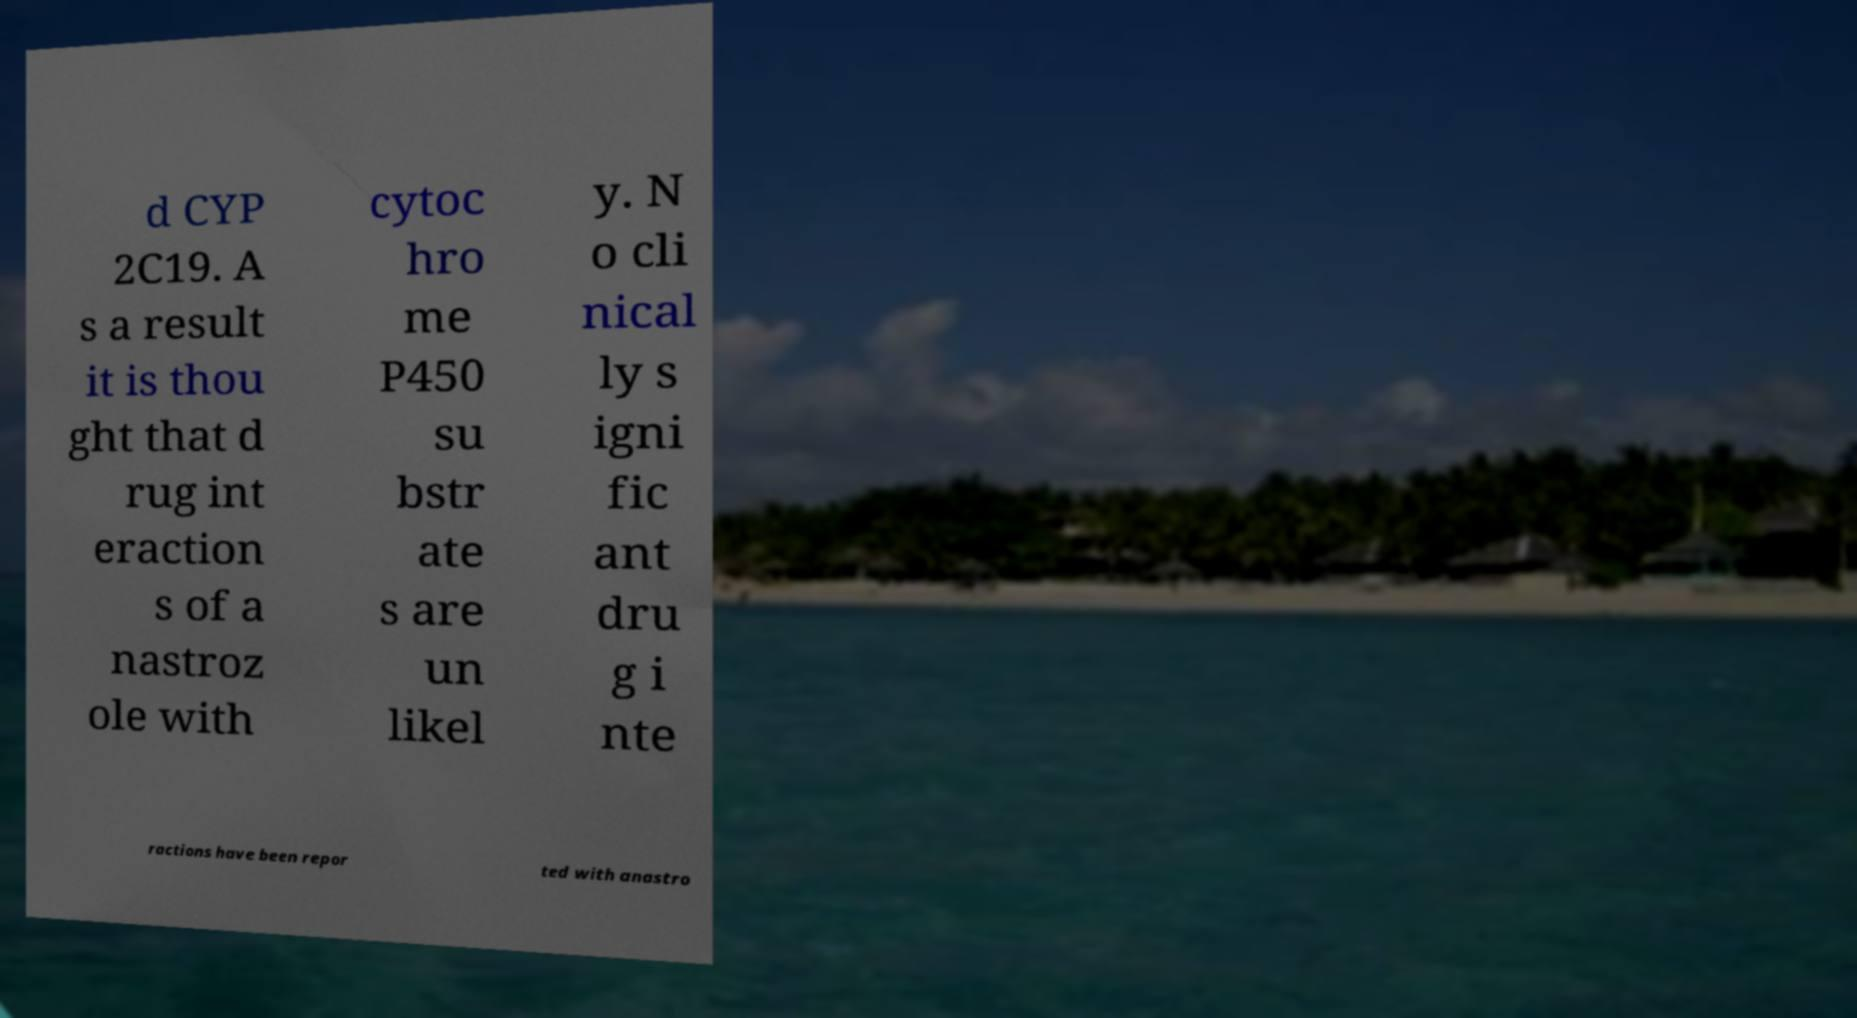There's text embedded in this image that I need extracted. Can you transcribe it verbatim? d CYP 2C19. A s a result it is thou ght that d rug int eraction s of a nastroz ole with cytoc hro me P450 su bstr ate s are un likel y. N o cli nical ly s igni fic ant dru g i nte ractions have been repor ted with anastro 